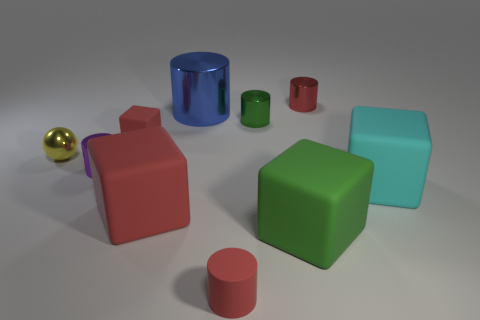Do the small rubber block and the tiny matte cylinder have the same color?
Provide a short and direct response. Yes. What size is the purple object that is the same shape as the small green object?
Provide a succinct answer. Small. Is there any other thing that has the same size as the yellow ball?
Provide a short and direct response. Yes. What is the red cylinder behind the tiny cylinder in front of the tiny purple object made of?
Give a very brief answer. Metal. How many rubber objects are gray objects or green cylinders?
Offer a terse response. 0. What color is the small rubber object that is the same shape as the blue shiny object?
Ensure brevity in your answer.  Red. How many objects are the same color as the tiny rubber cylinder?
Give a very brief answer. 3. Is there a big cyan matte object that is to the left of the shiny cylinder in front of the tiny yellow thing?
Provide a succinct answer. No. What number of objects are both to the left of the purple metallic object and on the right side of the red metallic thing?
Offer a terse response. 0. What number of tiny red things have the same material as the yellow ball?
Keep it short and to the point. 1. 